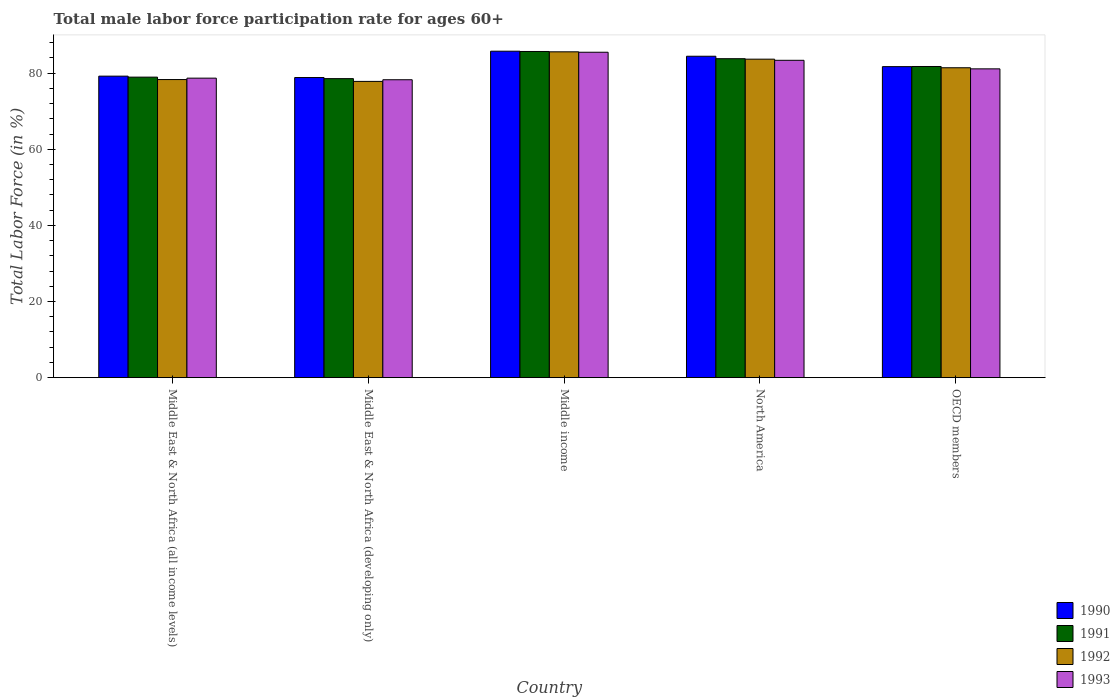How many different coloured bars are there?
Offer a very short reply. 4. How many bars are there on the 5th tick from the left?
Make the answer very short. 4. What is the label of the 1st group of bars from the left?
Offer a very short reply. Middle East & North Africa (all income levels). What is the male labor force participation rate in 1991 in Middle East & North Africa (all income levels)?
Your answer should be compact. 78.96. Across all countries, what is the maximum male labor force participation rate in 1990?
Your answer should be compact. 85.78. Across all countries, what is the minimum male labor force participation rate in 1992?
Make the answer very short. 77.85. In which country was the male labor force participation rate in 1992 maximum?
Offer a terse response. Middle income. In which country was the male labor force participation rate in 1990 minimum?
Offer a terse response. Middle East & North Africa (developing only). What is the total male labor force participation rate in 1991 in the graph?
Provide a short and direct response. 408.81. What is the difference between the male labor force participation rate in 1993 in Middle East & North Africa (all income levels) and that in Middle income?
Ensure brevity in your answer.  -6.81. What is the difference between the male labor force participation rate in 1993 in Middle income and the male labor force participation rate in 1992 in Middle East & North Africa (all income levels)?
Ensure brevity in your answer.  7.17. What is the average male labor force participation rate in 1990 per country?
Keep it short and to the point. 82.01. What is the difference between the male labor force participation rate of/in 1991 and male labor force participation rate of/in 1990 in Middle East & North Africa (developing only)?
Keep it short and to the point. -0.29. In how many countries, is the male labor force participation rate in 1991 greater than 8 %?
Offer a terse response. 5. What is the ratio of the male labor force participation rate in 1990 in Middle East & North Africa (all income levels) to that in Middle East & North Africa (developing only)?
Provide a short and direct response. 1. Is the difference between the male labor force participation rate in 1991 in Middle East & North Africa (developing only) and Middle income greater than the difference between the male labor force participation rate in 1990 in Middle East & North Africa (developing only) and Middle income?
Your answer should be compact. No. What is the difference between the highest and the second highest male labor force participation rate in 1990?
Offer a very short reply. -2.73. What is the difference between the highest and the lowest male labor force participation rate in 1990?
Provide a succinct answer. 6.92. What does the 2nd bar from the left in Middle income represents?
Make the answer very short. 1991. Is it the case that in every country, the sum of the male labor force participation rate in 1991 and male labor force participation rate in 1993 is greater than the male labor force participation rate in 1992?
Keep it short and to the point. Yes. Are all the bars in the graph horizontal?
Provide a succinct answer. No. How many countries are there in the graph?
Offer a very short reply. 5. What is the difference between two consecutive major ticks on the Y-axis?
Your answer should be very brief. 20. Are the values on the major ticks of Y-axis written in scientific E-notation?
Offer a terse response. No. Where does the legend appear in the graph?
Your answer should be very brief. Bottom right. What is the title of the graph?
Your response must be concise. Total male labor force participation rate for ages 60+. Does "1976" appear as one of the legend labels in the graph?
Make the answer very short. No. What is the label or title of the Y-axis?
Offer a very short reply. Total Labor Force (in %). What is the Total Labor Force (in %) in 1990 in Middle East & North Africa (all income levels)?
Your answer should be very brief. 79.22. What is the Total Labor Force (in %) in 1991 in Middle East & North Africa (all income levels)?
Your response must be concise. 78.96. What is the Total Labor Force (in %) in 1992 in Middle East & North Africa (all income levels)?
Your response must be concise. 78.33. What is the Total Labor Force (in %) in 1993 in Middle East & North Africa (all income levels)?
Make the answer very short. 78.7. What is the Total Labor Force (in %) of 1990 in Middle East & North Africa (developing only)?
Keep it short and to the point. 78.86. What is the Total Labor Force (in %) of 1991 in Middle East & North Africa (developing only)?
Offer a terse response. 78.57. What is the Total Labor Force (in %) in 1992 in Middle East & North Africa (developing only)?
Provide a short and direct response. 77.85. What is the Total Labor Force (in %) of 1993 in Middle East & North Africa (developing only)?
Your response must be concise. 78.28. What is the Total Labor Force (in %) of 1990 in Middle income?
Provide a succinct answer. 85.78. What is the Total Labor Force (in %) of 1991 in Middle income?
Keep it short and to the point. 85.71. What is the Total Labor Force (in %) of 1992 in Middle income?
Offer a very short reply. 85.62. What is the Total Labor Force (in %) of 1993 in Middle income?
Your answer should be compact. 85.5. What is the Total Labor Force (in %) in 1990 in North America?
Ensure brevity in your answer.  84.45. What is the Total Labor Force (in %) of 1991 in North America?
Ensure brevity in your answer.  83.81. What is the Total Labor Force (in %) in 1992 in North America?
Offer a terse response. 83.69. What is the Total Labor Force (in %) in 1993 in North America?
Ensure brevity in your answer.  83.39. What is the Total Labor Force (in %) of 1990 in OECD members?
Your answer should be very brief. 81.72. What is the Total Labor Force (in %) in 1991 in OECD members?
Offer a very short reply. 81.76. What is the Total Labor Force (in %) in 1992 in OECD members?
Keep it short and to the point. 81.43. What is the Total Labor Force (in %) in 1993 in OECD members?
Provide a short and direct response. 81.14. Across all countries, what is the maximum Total Labor Force (in %) in 1990?
Keep it short and to the point. 85.78. Across all countries, what is the maximum Total Labor Force (in %) in 1991?
Ensure brevity in your answer.  85.71. Across all countries, what is the maximum Total Labor Force (in %) of 1992?
Provide a short and direct response. 85.62. Across all countries, what is the maximum Total Labor Force (in %) in 1993?
Ensure brevity in your answer.  85.5. Across all countries, what is the minimum Total Labor Force (in %) of 1990?
Offer a terse response. 78.86. Across all countries, what is the minimum Total Labor Force (in %) of 1991?
Give a very brief answer. 78.57. Across all countries, what is the minimum Total Labor Force (in %) of 1992?
Offer a very short reply. 77.85. Across all countries, what is the minimum Total Labor Force (in %) of 1993?
Your response must be concise. 78.28. What is the total Total Labor Force (in %) in 1990 in the graph?
Make the answer very short. 410.04. What is the total Total Labor Force (in %) of 1991 in the graph?
Ensure brevity in your answer.  408.81. What is the total Total Labor Force (in %) in 1992 in the graph?
Ensure brevity in your answer.  406.91. What is the total Total Labor Force (in %) in 1993 in the graph?
Your answer should be compact. 407.01. What is the difference between the Total Labor Force (in %) in 1990 in Middle East & North Africa (all income levels) and that in Middle East & North Africa (developing only)?
Offer a very short reply. 0.37. What is the difference between the Total Labor Force (in %) in 1991 in Middle East & North Africa (all income levels) and that in Middle East & North Africa (developing only)?
Provide a succinct answer. 0.39. What is the difference between the Total Labor Force (in %) of 1992 in Middle East & North Africa (all income levels) and that in Middle East & North Africa (developing only)?
Offer a terse response. 0.48. What is the difference between the Total Labor Force (in %) of 1993 in Middle East & North Africa (all income levels) and that in Middle East & North Africa (developing only)?
Offer a very short reply. 0.42. What is the difference between the Total Labor Force (in %) of 1990 in Middle East & North Africa (all income levels) and that in Middle income?
Provide a short and direct response. -6.55. What is the difference between the Total Labor Force (in %) in 1991 in Middle East & North Africa (all income levels) and that in Middle income?
Your response must be concise. -6.74. What is the difference between the Total Labor Force (in %) of 1992 in Middle East & North Africa (all income levels) and that in Middle income?
Offer a very short reply. -7.29. What is the difference between the Total Labor Force (in %) of 1993 in Middle East & North Africa (all income levels) and that in Middle income?
Provide a succinct answer. -6.81. What is the difference between the Total Labor Force (in %) of 1990 in Middle East & North Africa (all income levels) and that in North America?
Keep it short and to the point. -5.23. What is the difference between the Total Labor Force (in %) of 1991 in Middle East & North Africa (all income levels) and that in North America?
Offer a terse response. -4.85. What is the difference between the Total Labor Force (in %) in 1992 in Middle East & North Africa (all income levels) and that in North America?
Keep it short and to the point. -5.36. What is the difference between the Total Labor Force (in %) in 1993 in Middle East & North Africa (all income levels) and that in North America?
Make the answer very short. -4.69. What is the difference between the Total Labor Force (in %) of 1990 in Middle East & North Africa (all income levels) and that in OECD members?
Provide a succinct answer. -2.5. What is the difference between the Total Labor Force (in %) in 1991 in Middle East & North Africa (all income levels) and that in OECD members?
Make the answer very short. -2.8. What is the difference between the Total Labor Force (in %) of 1992 in Middle East & North Africa (all income levels) and that in OECD members?
Provide a short and direct response. -3.1. What is the difference between the Total Labor Force (in %) in 1993 in Middle East & North Africa (all income levels) and that in OECD members?
Offer a very short reply. -2.45. What is the difference between the Total Labor Force (in %) in 1990 in Middle East & North Africa (developing only) and that in Middle income?
Provide a short and direct response. -6.92. What is the difference between the Total Labor Force (in %) of 1991 in Middle East & North Africa (developing only) and that in Middle income?
Provide a succinct answer. -7.13. What is the difference between the Total Labor Force (in %) of 1992 in Middle East & North Africa (developing only) and that in Middle income?
Make the answer very short. -7.77. What is the difference between the Total Labor Force (in %) in 1993 in Middle East & North Africa (developing only) and that in Middle income?
Ensure brevity in your answer.  -7.23. What is the difference between the Total Labor Force (in %) of 1990 in Middle East & North Africa (developing only) and that in North America?
Provide a short and direct response. -5.59. What is the difference between the Total Labor Force (in %) in 1991 in Middle East & North Africa (developing only) and that in North America?
Ensure brevity in your answer.  -5.24. What is the difference between the Total Labor Force (in %) of 1992 in Middle East & North Africa (developing only) and that in North America?
Ensure brevity in your answer.  -5.84. What is the difference between the Total Labor Force (in %) in 1993 in Middle East & North Africa (developing only) and that in North America?
Offer a very short reply. -5.11. What is the difference between the Total Labor Force (in %) in 1990 in Middle East & North Africa (developing only) and that in OECD members?
Your answer should be compact. -2.86. What is the difference between the Total Labor Force (in %) of 1991 in Middle East & North Africa (developing only) and that in OECD members?
Provide a short and direct response. -3.19. What is the difference between the Total Labor Force (in %) in 1992 in Middle East & North Africa (developing only) and that in OECD members?
Your answer should be very brief. -3.58. What is the difference between the Total Labor Force (in %) in 1993 in Middle East & North Africa (developing only) and that in OECD members?
Your answer should be very brief. -2.86. What is the difference between the Total Labor Force (in %) of 1990 in Middle income and that in North America?
Provide a short and direct response. 1.33. What is the difference between the Total Labor Force (in %) of 1991 in Middle income and that in North America?
Your answer should be compact. 1.9. What is the difference between the Total Labor Force (in %) in 1992 in Middle income and that in North America?
Ensure brevity in your answer.  1.93. What is the difference between the Total Labor Force (in %) of 1993 in Middle income and that in North America?
Make the answer very short. 2.12. What is the difference between the Total Labor Force (in %) in 1990 in Middle income and that in OECD members?
Your answer should be compact. 4.06. What is the difference between the Total Labor Force (in %) of 1991 in Middle income and that in OECD members?
Your answer should be very brief. 3.95. What is the difference between the Total Labor Force (in %) in 1992 in Middle income and that in OECD members?
Keep it short and to the point. 4.19. What is the difference between the Total Labor Force (in %) of 1993 in Middle income and that in OECD members?
Provide a succinct answer. 4.36. What is the difference between the Total Labor Force (in %) in 1990 in North America and that in OECD members?
Your answer should be compact. 2.73. What is the difference between the Total Labor Force (in %) in 1991 in North America and that in OECD members?
Keep it short and to the point. 2.05. What is the difference between the Total Labor Force (in %) in 1992 in North America and that in OECD members?
Your answer should be compact. 2.26. What is the difference between the Total Labor Force (in %) of 1993 in North America and that in OECD members?
Make the answer very short. 2.25. What is the difference between the Total Labor Force (in %) of 1990 in Middle East & North Africa (all income levels) and the Total Labor Force (in %) of 1991 in Middle East & North Africa (developing only)?
Provide a short and direct response. 0.65. What is the difference between the Total Labor Force (in %) of 1990 in Middle East & North Africa (all income levels) and the Total Labor Force (in %) of 1992 in Middle East & North Africa (developing only)?
Provide a short and direct response. 1.38. What is the difference between the Total Labor Force (in %) of 1990 in Middle East & North Africa (all income levels) and the Total Labor Force (in %) of 1993 in Middle East & North Africa (developing only)?
Offer a terse response. 0.94. What is the difference between the Total Labor Force (in %) in 1991 in Middle East & North Africa (all income levels) and the Total Labor Force (in %) in 1992 in Middle East & North Africa (developing only)?
Your answer should be compact. 1.12. What is the difference between the Total Labor Force (in %) in 1991 in Middle East & North Africa (all income levels) and the Total Labor Force (in %) in 1993 in Middle East & North Africa (developing only)?
Keep it short and to the point. 0.68. What is the difference between the Total Labor Force (in %) of 1992 in Middle East & North Africa (all income levels) and the Total Labor Force (in %) of 1993 in Middle East & North Africa (developing only)?
Give a very brief answer. 0.05. What is the difference between the Total Labor Force (in %) in 1990 in Middle East & North Africa (all income levels) and the Total Labor Force (in %) in 1991 in Middle income?
Your answer should be very brief. -6.48. What is the difference between the Total Labor Force (in %) of 1990 in Middle East & North Africa (all income levels) and the Total Labor Force (in %) of 1992 in Middle income?
Offer a very short reply. -6.39. What is the difference between the Total Labor Force (in %) in 1990 in Middle East & North Africa (all income levels) and the Total Labor Force (in %) in 1993 in Middle income?
Your response must be concise. -6.28. What is the difference between the Total Labor Force (in %) of 1991 in Middle East & North Africa (all income levels) and the Total Labor Force (in %) of 1992 in Middle income?
Give a very brief answer. -6.65. What is the difference between the Total Labor Force (in %) of 1991 in Middle East & North Africa (all income levels) and the Total Labor Force (in %) of 1993 in Middle income?
Provide a succinct answer. -6.54. What is the difference between the Total Labor Force (in %) of 1992 in Middle East & North Africa (all income levels) and the Total Labor Force (in %) of 1993 in Middle income?
Make the answer very short. -7.17. What is the difference between the Total Labor Force (in %) of 1990 in Middle East & North Africa (all income levels) and the Total Labor Force (in %) of 1991 in North America?
Your answer should be compact. -4.59. What is the difference between the Total Labor Force (in %) of 1990 in Middle East & North Africa (all income levels) and the Total Labor Force (in %) of 1992 in North America?
Ensure brevity in your answer.  -4.46. What is the difference between the Total Labor Force (in %) of 1990 in Middle East & North Africa (all income levels) and the Total Labor Force (in %) of 1993 in North America?
Keep it short and to the point. -4.16. What is the difference between the Total Labor Force (in %) of 1991 in Middle East & North Africa (all income levels) and the Total Labor Force (in %) of 1992 in North America?
Offer a terse response. -4.72. What is the difference between the Total Labor Force (in %) of 1991 in Middle East & North Africa (all income levels) and the Total Labor Force (in %) of 1993 in North America?
Offer a very short reply. -4.42. What is the difference between the Total Labor Force (in %) in 1992 in Middle East & North Africa (all income levels) and the Total Labor Force (in %) in 1993 in North America?
Offer a terse response. -5.06. What is the difference between the Total Labor Force (in %) of 1990 in Middle East & North Africa (all income levels) and the Total Labor Force (in %) of 1991 in OECD members?
Offer a terse response. -2.54. What is the difference between the Total Labor Force (in %) of 1990 in Middle East & North Africa (all income levels) and the Total Labor Force (in %) of 1992 in OECD members?
Ensure brevity in your answer.  -2.21. What is the difference between the Total Labor Force (in %) of 1990 in Middle East & North Africa (all income levels) and the Total Labor Force (in %) of 1993 in OECD members?
Offer a very short reply. -1.92. What is the difference between the Total Labor Force (in %) of 1991 in Middle East & North Africa (all income levels) and the Total Labor Force (in %) of 1992 in OECD members?
Provide a succinct answer. -2.47. What is the difference between the Total Labor Force (in %) in 1991 in Middle East & North Africa (all income levels) and the Total Labor Force (in %) in 1993 in OECD members?
Your answer should be compact. -2.18. What is the difference between the Total Labor Force (in %) of 1992 in Middle East & North Africa (all income levels) and the Total Labor Force (in %) of 1993 in OECD members?
Offer a very short reply. -2.81. What is the difference between the Total Labor Force (in %) in 1990 in Middle East & North Africa (developing only) and the Total Labor Force (in %) in 1991 in Middle income?
Provide a short and direct response. -6.85. What is the difference between the Total Labor Force (in %) of 1990 in Middle East & North Africa (developing only) and the Total Labor Force (in %) of 1992 in Middle income?
Ensure brevity in your answer.  -6.76. What is the difference between the Total Labor Force (in %) of 1990 in Middle East & North Africa (developing only) and the Total Labor Force (in %) of 1993 in Middle income?
Your response must be concise. -6.65. What is the difference between the Total Labor Force (in %) of 1991 in Middle East & North Africa (developing only) and the Total Labor Force (in %) of 1992 in Middle income?
Ensure brevity in your answer.  -7.04. What is the difference between the Total Labor Force (in %) in 1991 in Middle East & North Africa (developing only) and the Total Labor Force (in %) in 1993 in Middle income?
Provide a short and direct response. -6.93. What is the difference between the Total Labor Force (in %) in 1992 in Middle East & North Africa (developing only) and the Total Labor Force (in %) in 1993 in Middle income?
Keep it short and to the point. -7.66. What is the difference between the Total Labor Force (in %) in 1990 in Middle East & North Africa (developing only) and the Total Labor Force (in %) in 1991 in North America?
Provide a short and direct response. -4.95. What is the difference between the Total Labor Force (in %) in 1990 in Middle East & North Africa (developing only) and the Total Labor Force (in %) in 1992 in North America?
Your response must be concise. -4.83. What is the difference between the Total Labor Force (in %) of 1990 in Middle East & North Africa (developing only) and the Total Labor Force (in %) of 1993 in North America?
Offer a very short reply. -4.53. What is the difference between the Total Labor Force (in %) in 1991 in Middle East & North Africa (developing only) and the Total Labor Force (in %) in 1992 in North America?
Give a very brief answer. -5.11. What is the difference between the Total Labor Force (in %) in 1991 in Middle East & North Africa (developing only) and the Total Labor Force (in %) in 1993 in North America?
Offer a terse response. -4.81. What is the difference between the Total Labor Force (in %) in 1992 in Middle East & North Africa (developing only) and the Total Labor Force (in %) in 1993 in North America?
Give a very brief answer. -5.54. What is the difference between the Total Labor Force (in %) of 1990 in Middle East & North Africa (developing only) and the Total Labor Force (in %) of 1991 in OECD members?
Make the answer very short. -2.9. What is the difference between the Total Labor Force (in %) of 1990 in Middle East & North Africa (developing only) and the Total Labor Force (in %) of 1992 in OECD members?
Your answer should be very brief. -2.57. What is the difference between the Total Labor Force (in %) of 1990 in Middle East & North Africa (developing only) and the Total Labor Force (in %) of 1993 in OECD members?
Your answer should be very brief. -2.28. What is the difference between the Total Labor Force (in %) of 1991 in Middle East & North Africa (developing only) and the Total Labor Force (in %) of 1992 in OECD members?
Keep it short and to the point. -2.86. What is the difference between the Total Labor Force (in %) of 1991 in Middle East & North Africa (developing only) and the Total Labor Force (in %) of 1993 in OECD members?
Keep it short and to the point. -2.57. What is the difference between the Total Labor Force (in %) of 1992 in Middle East & North Africa (developing only) and the Total Labor Force (in %) of 1993 in OECD members?
Make the answer very short. -3.3. What is the difference between the Total Labor Force (in %) of 1990 in Middle income and the Total Labor Force (in %) of 1991 in North America?
Provide a short and direct response. 1.97. What is the difference between the Total Labor Force (in %) in 1990 in Middle income and the Total Labor Force (in %) in 1992 in North America?
Offer a terse response. 2.09. What is the difference between the Total Labor Force (in %) of 1990 in Middle income and the Total Labor Force (in %) of 1993 in North America?
Keep it short and to the point. 2.39. What is the difference between the Total Labor Force (in %) in 1991 in Middle income and the Total Labor Force (in %) in 1992 in North America?
Provide a succinct answer. 2.02. What is the difference between the Total Labor Force (in %) in 1991 in Middle income and the Total Labor Force (in %) in 1993 in North America?
Give a very brief answer. 2.32. What is the difference between the Total Labor Force (in %) in 1992 in Middle income and the Total Labor Force (in %) in 1993 in North America?
Provide a succinct answer. 2.23. What is the difference between the Total Labor Force (in %) of 1990 in Middle income and the Total Labor Force (in %) of 1991 in OECD members?
Keep it short and to the point. 4.02. What is the difference between the Total Labor Force (in %) in 1990 in Middle income and the Total Labor Force (in %) in 1992 in OECD members?
Offer a very short reply. 4.35. What is the difference between the Total Labor Force (in %) in 1990 in Middle income and the Total Labor Force (in %) in 1993 in OECD members?
Offer a very short reply. 4.64. What is the difference between the Total Labor Force (in %) in 1991 in Middle income and the Total Labor Force (in %) in 1992 in OECD members?
Provide a succinct answer. 4.28. What is the difference between the Total Labor Force (in %) of 1991 in Middle income and the Total Labor Force (in %) of 1993 in OECD members?
Offer a terse response. 4.57. What is the difference between the Total Labor Force (in %) of 1992 in Middle income and the Total Labor Force (in %) of 1993 in OECD members?
Offer a very short reply. 4.48. What is the difference between the Total Labor Force (in %) of 1990 in North America and the Total Labor Force (in %) of 1991 in OECD members?
Your response must be concise. 2.69. What is the difference between the Total Labor Force (in %) in 1990 in North America and the Total Labor Force (in %) in 1992 in OECD members?
Your answer should be compact. 3.02. What is the difference between the Total Labor Force (in %) in 1990 in North America and the Total Labor Force (in %) in 1993 in OECD members?
Make the answer very short. 3.31. What is the difference between the Total Labor Force (in %) of 1991 in North America and the Total Labor Force (in %) of 1992 in OECD members?
Offer a very short reply. 2.38. What is the difference between the Total Labor Force (in %) of 1991 in North America and the Total Labor Force (in %) of 1993 in OECD members?
Your answer should be compact. 2.67. What is the difference between the Total Labor Force (in %) in 1992 in North America and the Total Labor Force (in %) in 1993 in OECD members?
Give a very brief answer. 2.54. What is the average Total Labor Force (in %) in 1990 per country?
Keep it short and to the point. 82.01. What is the average Total Labor Force (in %) in 1991 per country?
Your answer should be compact. 81.76. What is the average Total Labor Force (in %) of 1992 per country?
Your response must be concise. 81.38. What is the average Total Labor Force (in %) in 1993 per country?
Your answer should be very brief. 81.4. What is the difference between the Total Labor Force (in %) in 1990 and Total Labor Force (in %) in 1991 in Middle East & North Africa (all income levels)?
Your answer should be compact. 0.26. What is the difference between the Total Labor Force (in %) of 1990 and Total Labor Force (in %) of 1992 in Middle East & North Africa (all income levels)?
Offer a terse response. 0.89. What is the difference between the Total Labor Force (in %) of 1990 and Total Labor Force (in %) of 1993 in Middle East & North Africa (all income levels)?
Your answer should be very brief. 0.53. What is the difference between the Total Labor Force (in %) of 1991 and Total Labor Force (in %) of 1992 in Middle East & North Africa (all income levels)?
Make the answer very short. 0.63. What is the difference between the Total Labor Force (in %) of 1991 and Total Labor Force (in %) of 1993 in Middle East & North Africa (all income levels)?
Make the answer very short. 0.27. What is the difference between the Total Labor Force (in %) of 1992 and Total Labor Force (in %) of 1993 in Middle East & North Africa (all income levels)?
Your answer should be very brief. -0.37. What is the difference between the Total Labor Force (in %) in 1990 and Total Labor Force (in %) in 1991 in Middle East & North Africa (developing only)?
Provide a short and direct response. 0.29. What is the difference between the Total Labor Force (in %) of 1990 and Total Labor Force (in %) of 1992 in Middle East & North Africa (developing only)?
Your answer should be very brief. 1.01. What is the difference between the Total Labor Force (in %) in 1990 and Total Labor Force (in %) in 1993 in Middle East & North Africa (developing only)?
Offer a very short reply. 0.58. What is the difference between the Total Labor Force (in %) in 1991 and Total Labor Force (in %) in 1992 in Middle East & North Africa (developing only)?
Provide a succinct answer. 0.73. What is the difference between the Total Labor Force (in %) of 1991 and Total Labor Force (in %) of 1993 in Middle East & North Africa (developing only)?
Your answer should be very brief. 0.29. What is the difference between the Total Labor Force (in %) of 1992 and Total Labor Force (in %) of 1993 in Middle East & North Africa (developing only)?
Your answer should be compact. -0.43. What is the difference between the Total Labor Force (in %) in 1990 and Total Labor Force (in %) in 1991 in Middle income?
Provide a succinct answer. 0.07. What is the difference between the Total Labor Force (in %) of 1990 and Total Labor Force (in %) of 1992 in Middle income?
Your answer should be very brief. 0.16. What is the difference between the Total Labor Force (in %) in 1990 and Total Labor Force (in %) in 1993 in Middle income?
Offer a very short reply. 0.27. What is the difference between the Total Labor Force (in %) in 1991 and Total Labor Force (in %) in 1992 in Middle income?
Provide a short and direct response. 0.09. What is the difference between the Total Labor Force (in %) in 1991 and Total Labor Force (in %) in 1993 in Middle income?
Make the answer very short. 0.2. What is the difference between the Total Labor Force (in %) in 1992 and Total Labor Force (in %) in 1993 in Middle income?
Make the answer very short. 0.11. What is the difference between the Total Labor Force (in %) in 1990 and Total Labor Force (in %) in 1991 in North America?
Offer a terse response. 0.64. What is the difference between the Total Labor Force (in %) of 1990 and Total Labor Force (in %) of 1992 in North America?
Offer a very short reply. 0.77. What is the difference between the Total Labor Force (in %) of 1990 and Total Labor Force (in %) of 1993 in North America?
Provide a short and direct response. 1.07. What is the difference between the Total Labor Force (in %) of 1991 and Total Labor Force (in %) of 1992 in North America?
Keep it short and to the point. 0.12. What is the difference between the Total Labor Force (in %) in 1991 and Total Labor Force (in %) in 1993 in North America?
Ensure brevity in your answer.  0.42. What is the difference between the Total Labor Force (in %) of 1992 and Total Labor Force (in %) of 1993 in North America?
Provide a succinct answer. 0.3. What is the difference between the Total Labor Force (in %) in 1990 and Total Labor Force (in %) in 1991 in OECD members?
Provide a short and direct response. -0.04. What is the difference between the Total Labor Force (in %) of 1990 and Total Labor Force (in %) of 1992 in OECD members?
Give a very brief answer. 0.29. What is the difference between the Total Labor Force (in %) of 1990 and Total Labor Force (in %) of 1993 in OECD members?
Your answer should be compact. 0.58. What is the difference between the Total Labor Force (in %) of 1991 and Total Labor Force (in %) of 1992 in OECD members?
Ensure brevity in your answer.  0.33. What is the difference between the Total Labor Force (in %) of 1991 and Total Labor Force (in %) of 1993 in OECD members?
Keep it short and to the point. 0.62. What is the difference between the Total Labor Force (in %) of 1992 and Total Labor Force (in %) of 1993 in OECD members?
Ensure brevity in your answer.  0.29. What is the ratio of the Total Labor Force (in %) of 1991 in Middle East & North Africa (all income levels) to that in Middle East & North Africa (developing only)?
Offer a very short reply. 1. What is the ratio of the Total Labor Force (in %) of 1990 in Middle East & North Africa (all income levels) to that in Middle income?
Offer a very short reply. 0.92. What is the ratio of the Total Labor Force (in %) of 1991 in Middle East & North Africa (all income levels) to that in Middle income?
Ensure brevity in your answer.  0.92. What is the ratio of the Total Labor Force (in %) of 1992 in Middle East & North Africa (all income levels) to that in Middle income?
Make the answer very short. 0.91. What is the ratio of the Total Labor Force (in %) of 1993 in Middle East & North Africa (all income levels) to that in Middle income?
Offer a terse response. 0.92. What is the ratio of the Total Labor Force (in %) in 1990 in Middle East & North Africa (all income levels) to that in North America?
Provide a short and direct response. 0.94. What is the ratio of the Total Labor Force (in %) in 1991 in Middle East & North Africa (all income levels) to that in North America?
Provide a succinct answer. 0.94. What is the ratio of the Total Labor Force (in %) in 1992 in Middle East & North Africa (all income levels) to that in North America?
Offer a terse response. 0.94. What is the ratio of the Total Labor Force (in %) in 1993 in Middle East & North Africa (all income levels) to that in North America?
Your response must be concise. 0.94. What is the ratio of the Total Labor Force (in %) in 1990 in Middle East & North Africa (all income levels) to that in OECD members?
Your answer should be very brief. 0.97. What is the ratio of the Total Labor Force (in %) in 1991 in Middle East & North Africa (all income levels) to that in OECD members?
Give a very brief answer. 0.97. What is the ratio of the Total Labor Force (in %) in 1992 in Middle East & North Africa (all income levels) to that in OECD members?
Offer a terse response. 0.96. What is the ratio of the Total Labor Force (in %) of 1993 in Middle East & North Africa (all income levels) to that in OECD members?
Your answer should be compact. 0.97. What is the ratio of the Total Labor Force (in %) of 1990 in Middle East & North Africa (developing only) to that in Middle income?
Offer a very short reply. 0.92. What is the ratio of the Total Labor Force (in %) of 1991 in Middle East & North Africa (developing only) to that in Middle income?
Ensure brevity in your answer.  0.92. What is the ratio of the Total Labor Force (in %) of 1992 in Middle East & North Africa (developing only) to that in Middle income?
Provide a short and direct response. 0.91. What is the ratio of the Total Labor Force (in %) in 1993 in Middle East & North Africa (developing only) to that in Middle income?
Make the answer very short. 0.92. What is the ratio of the Total Labor Force (in %) of 1990 in Middle East & North Africa (developing only) to that in North America?
Provide a succinct answer. 0.93. What is the ratio of the Total Labor Force (in %) of 1992 in Middle East & North Africa (developing only) to that in North America?
Your answer should be compact. 0.93. What is the ratio of the Total Labor Force (in %) of 1993 in Middle East & North Africa (developing only) to that in North America?
Ensure brevity in your answer.  0.94. What is the ratio of the Total Labor Force (in %) in 1990 in Middle East & North Africa (developing only) to that in OECD members?
Your response must be concise. 0.96. What is the ratio of the Total Labor Force (in %) in 1991 in Middle East & North Africa (developing only) to that in OECD members?
Keep it short and to the point. 0.96. What is the ratio of the Total Labor Force (in %) in 1992 in Middle East & North Africa (developing only) to that in OECD members?
Keep it short and to the point. 0.96. What is the ratio of the Total Labor Force (in %) of 1993 in Middle East & North Africa (developing only) to that in OECD members?
Your response must be concise. 0.96. What is the ratio of the Total Labor Force (in %) of 1990 in Middle income to that in North America?
Ensure brevity in your answer.  1.02. What is the ratio of the Total Labor Force (in %) in 1991 in Middle income to that in North America?
Give a very brief answer. 1.02. What is the ratio of the Total Labor Force (in %) of 1992 in Middle income to that in North America?
Give a very brief answer. 1.02. What is the ratio of the Total Labor Force (in %) in 1993 in Middle income to that in North America?
Ensure brevity in your answer.  1.03. What is the ratio of the Total Labor Force (in %) in 1990 in Middle income to that in OECD members?
Make the answer very short. 1.05. What is the ratio of the Total Labor Force (in %) of 1991 in Middle income to that in OECD members?
Your answer should be very brief. 1.05. What is the ratio of the Total Labor Force (in %) in 1992 in Middle income to that in OECD members?
Make the answer very short. 1.05. What is the ratio of the Total Labor Force (in %) in 1993 in Middle income to that in OECD members?
Provide a short and direct response. 1.05. What is the ratio of the Total Labor Force (in %) in 1990 in North America to that in OECD members?
Offer a terse response. 1.03. What is the ratio of the Total Labor Force (in %) in 1991 in North America to that in OECD members?
Provide a succinct answer. 1.03. What is the ratio of the Total Labor Force (in %) in 1992 in North America to that in OECD members?
Provide a short and direct response. 1.03. What is the ratio of the Total Labor Force (in %) of 1993 in North America to that in OECD members?
Give a very brief answer. 1.03. What is the difference between the highest and the second highest Total Labor Force (in %) in 1990?
Make the answer very short. 1.33. What is the difference between the highest and the second highest Total Labor Force (in %) in 1991?
Make the answer very short. 1.9. What is the difference between the highest and the second highest Total Labor Force (in %) of 1992?
Offer a very short reply. 1.93. What is the difference between the highest and the second highest Total Labor Force (in %) of 1993?
Offer a terse response. 2.12. What is the difference between the highest and the lowest Total Labor Force (in %) in 1990?
Your answer should be compact. 6.92. What is the difference between the highest and the lowest Total Labor Force (in %) of 1991?
Make the answer very short. 7.13. What is the difference between the highest and the lowest Total Labor Force (in %) of 1992?
Your answer should be compact. 7.77. What is the difference between the highest and the lowest Total Labor Force (in %) in 1993?
Provide a succinct answer. 7.23. 